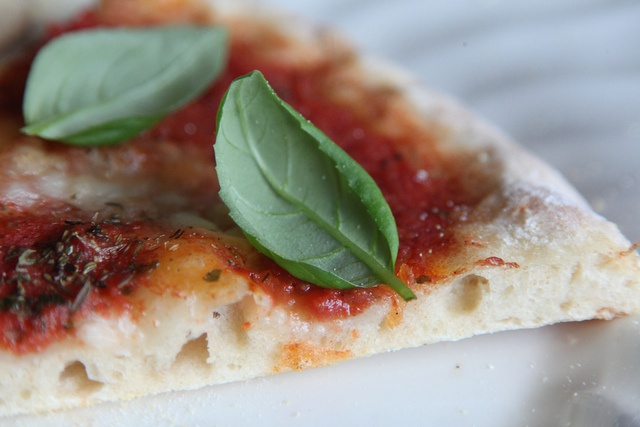Describe the objects in this image and their specific colors. I can see a pizza in darkgray, maroon, lightgray, and gray tones in this image. 